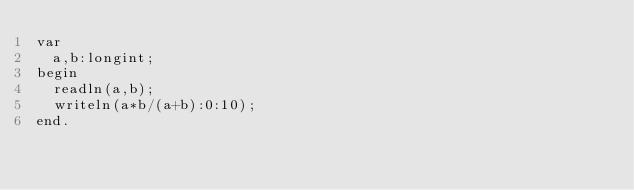<code> <loc_0><loc_0><loc_500><loc_500><_Pascal_>var
  a,b:longint;
begin
  readln(a,b);
  writeln(a*b/(a+b):0:10);
end.</code> 